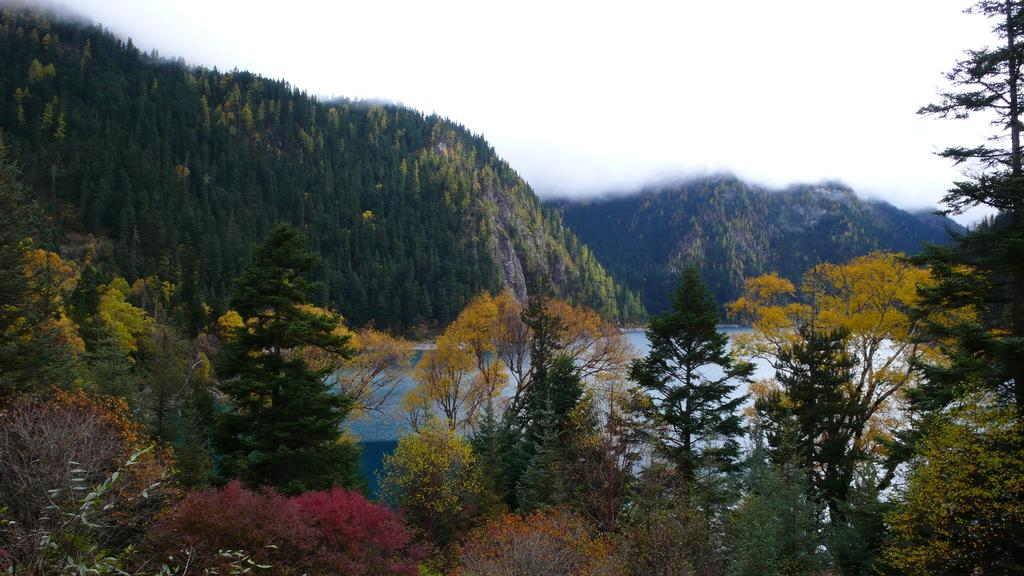What type of vegetation can be seen in the image? There are trees in the image. What natural feature is visible in the image? There is water visible in the image. What geographical feature can be seen in the distance? There are mountains in the image. What atmospheric condition is present in the image? Fog is present in the image. What can be seen in the background of the image? The sky is visible in the background of the image. Can you see any stars in the image? There are no stars visible in the image; the sky is obscured by fog. Is there a fire burning in the image? There is no fire present in the image. 